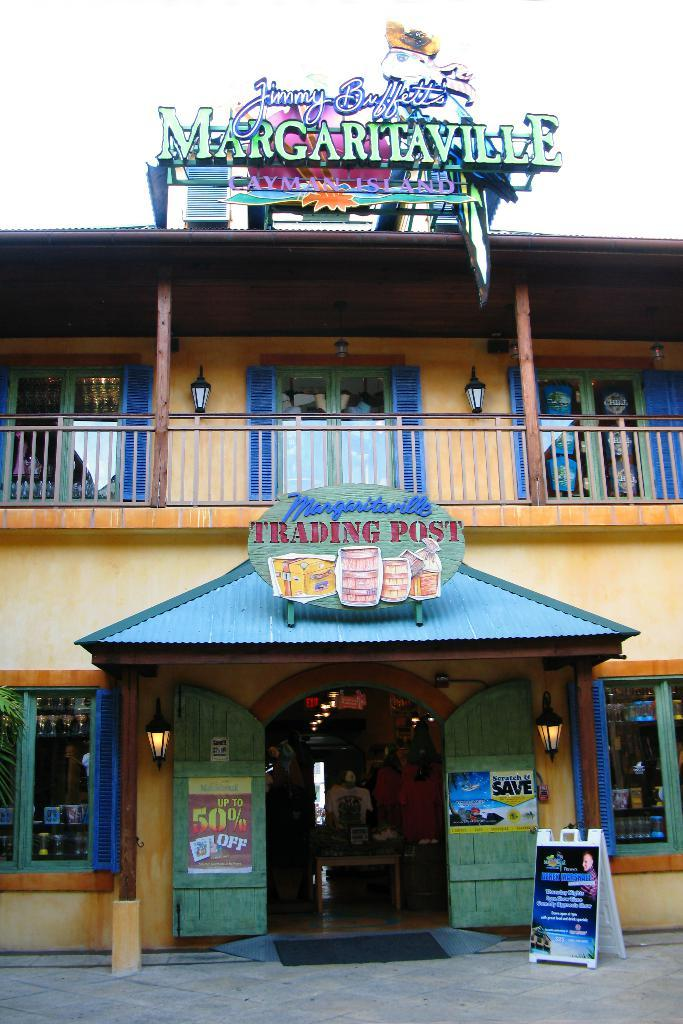<image>
Describe the image concisely. A restaurant with the entrance described as the trading post. 